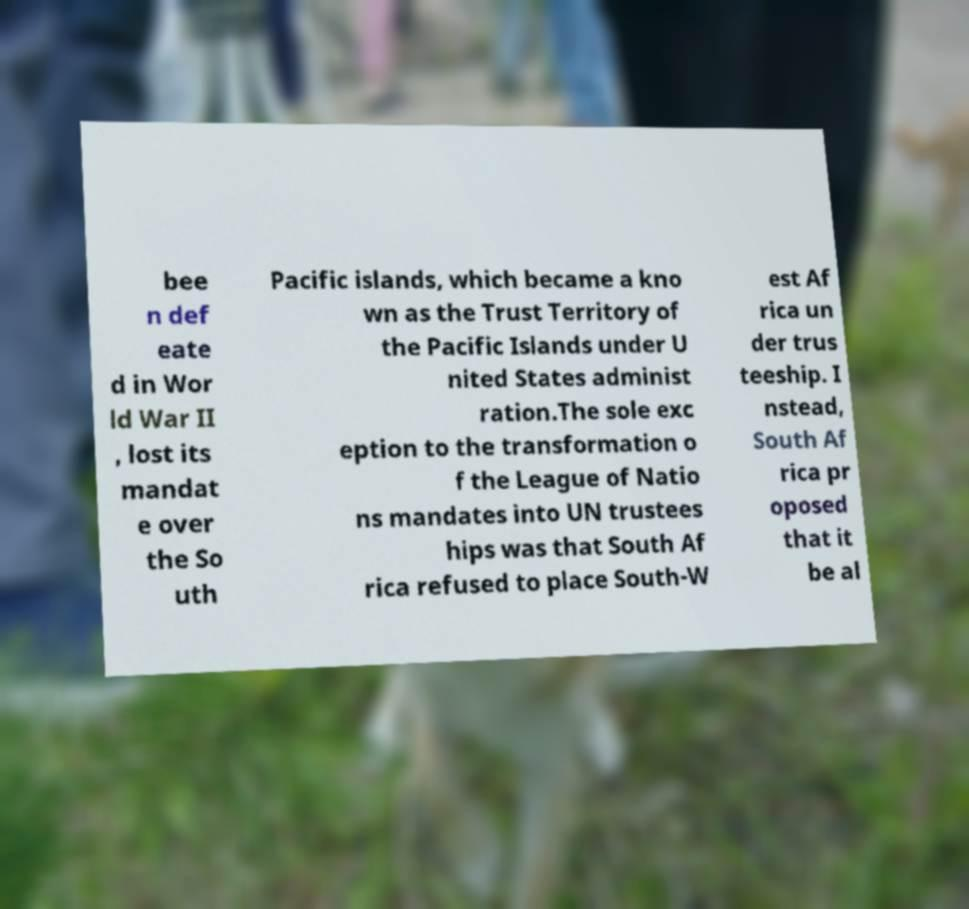I need the written content from this picture converted into text. Can you do that? bee n def eate d in Wor ld War II , lost its mandat e over the So uth Pacific islands, which became a kno wn as the Trust Territory of the Pacific Islands under U nited States administ ration.The sole exc eption to the transformation o f the League of Natio ns mandates into UN trustees hips was that South Af rica refused to place South-W est Af rica un der trus teeship. I nstead, South Af rica pr oposed that it be al 